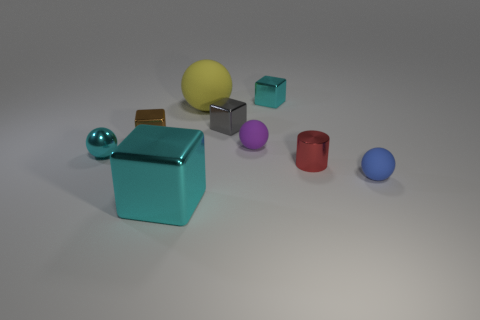What is the shape of the matte object in front of the small cyan thing that is to the left of the tiny matte thing that is on the left side of the blue sphere?
Provide a short and direct response. Sphere. Are there any purple spheres of the same size as the purple thing?
Make the answer very short. No. What size is the purple matte sphere?
Provide a short and direct response. Small. What number of cyan balls have the same size as the brown object?
Offer a terse response. 1. Are there fewer tiny gray blocks behind the yellow thing than small gray objects that are left of the cyan shiny sphere?
Keep it short and to the point. No. What size is the cyan metal cube that is in front of the tiny matte thing that is on the left side of the blue thing that is to the right of the red cylinder?
Make the answer very short. Large. There is a object that is both to the left of the blue object and on the right side of the small cyan metallic cube; how big is it?
Offer a terse response. Small. The cyan metal thing that is on the right side of the large object behind the large shiny thing is what shape?
Your response must be concise. Cube. Is there anything else that is the same color as the cylinder?
Give a very brief answer. No. The cyan metallic thing that is on the left side of the brown thing has what shape?
Provide a succinct answer. Sphere. 